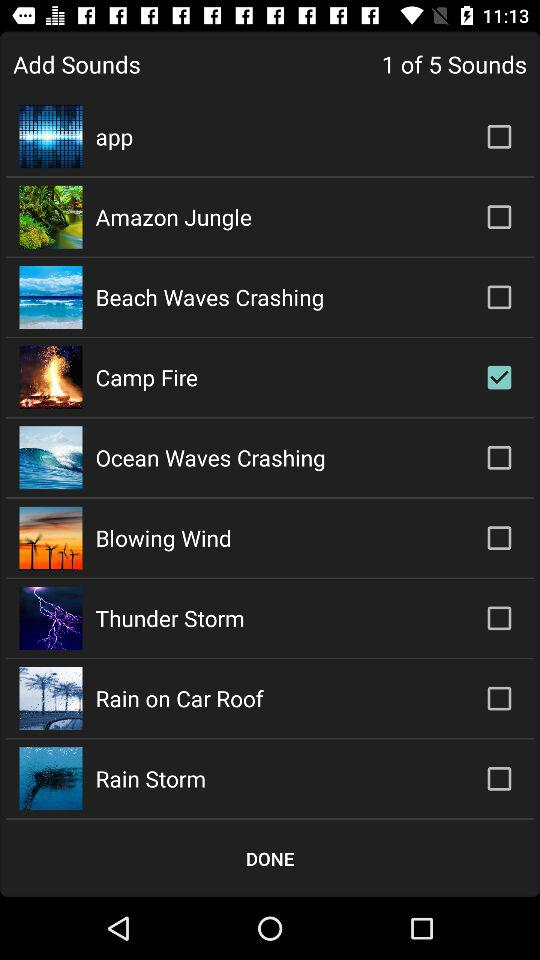What's the selected sound? The selected sound is "Camp Fire". 